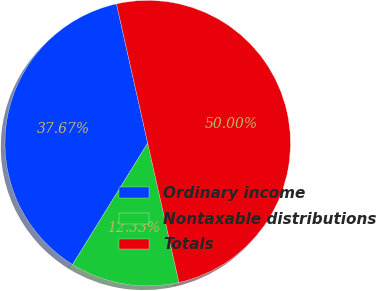Convert chart. <chart><loc_0><loc_0><loc_500><loc_500><pie_chart><fcel>Ordinary income<fcel>Nontaxable distributions<fcel>Totals<nl><fcel>37.67%<fcel>12.33%<fcel>50.0%<nl></chart> 